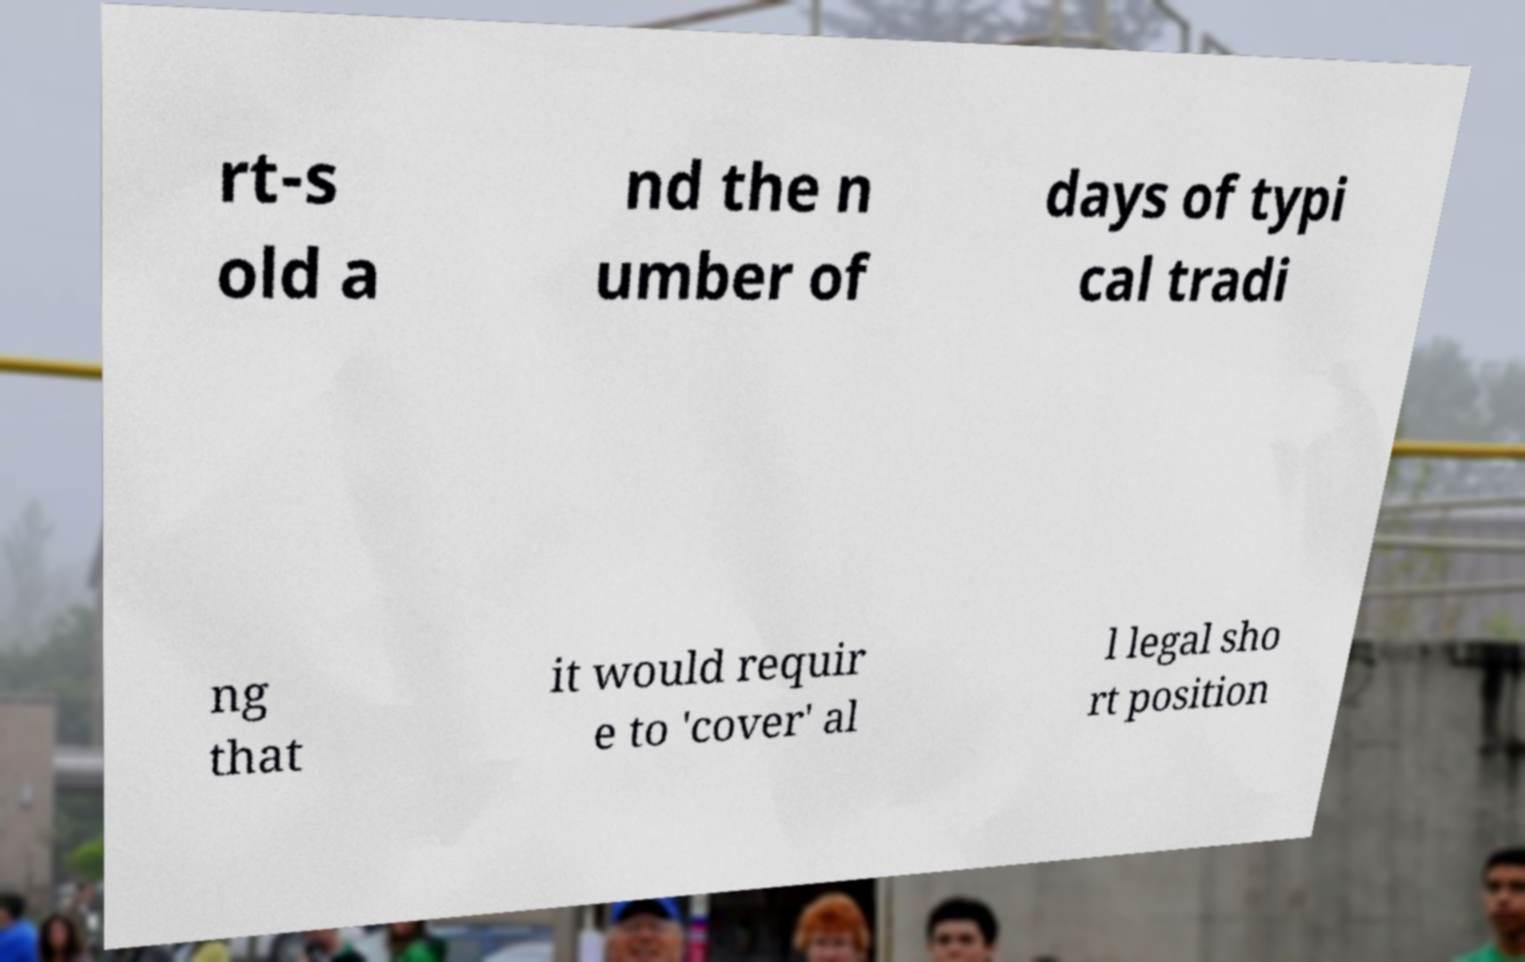There's text embedded in this image that I need extracted. Can you transcribe it verbatim? rt-s old a nd the n umber of days of typi cal tradi ng that it would requir e to 'cover' al l legal sho rt position 